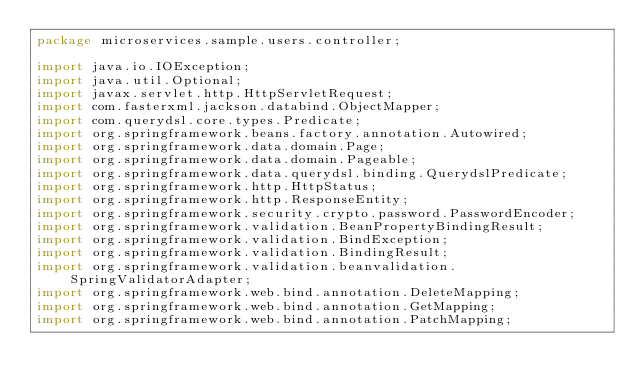Convert code to text. <code><loc_0><loc_0><loc_500><loc_500><_Java_>package microservices.sample.users.controller;

import java.io.IOException;
import java.util.Optional;
import javax.servlet.http.HttpServletRequest;
import com.fasterxml.jackson.databind.ObjectMapper;
import com.querydsl.core.types.Predicate;
import org.springframework.beans.factory.annotation.Autowired;
import org.springframework.data.domain.Page;
import org.springframework.data.domain.Pageable;
import org.springframework.data.querydsl.binding.QuerydslPredicate;
import org.springframework.http.HttpStatus;
import org.springframework.http.ResponseEntity;
import org.springframework.security.crypto.password.PasswordEncoder;
import org.springframework.validation.BeanPropertyBindingResult;
import org.springframework.validation.BindException;
import org.springframework.validation.BindingResult;
import org.springframework.validation.beanvalidation.SpringValidatorAdapter;
import org.springframework.web.bind.annotation.DeleteMapping;
import org.springframework.web.bind.annotation.GetMapping;
import org.springframework.web.bind.annotation.PatchMapping;</code> 